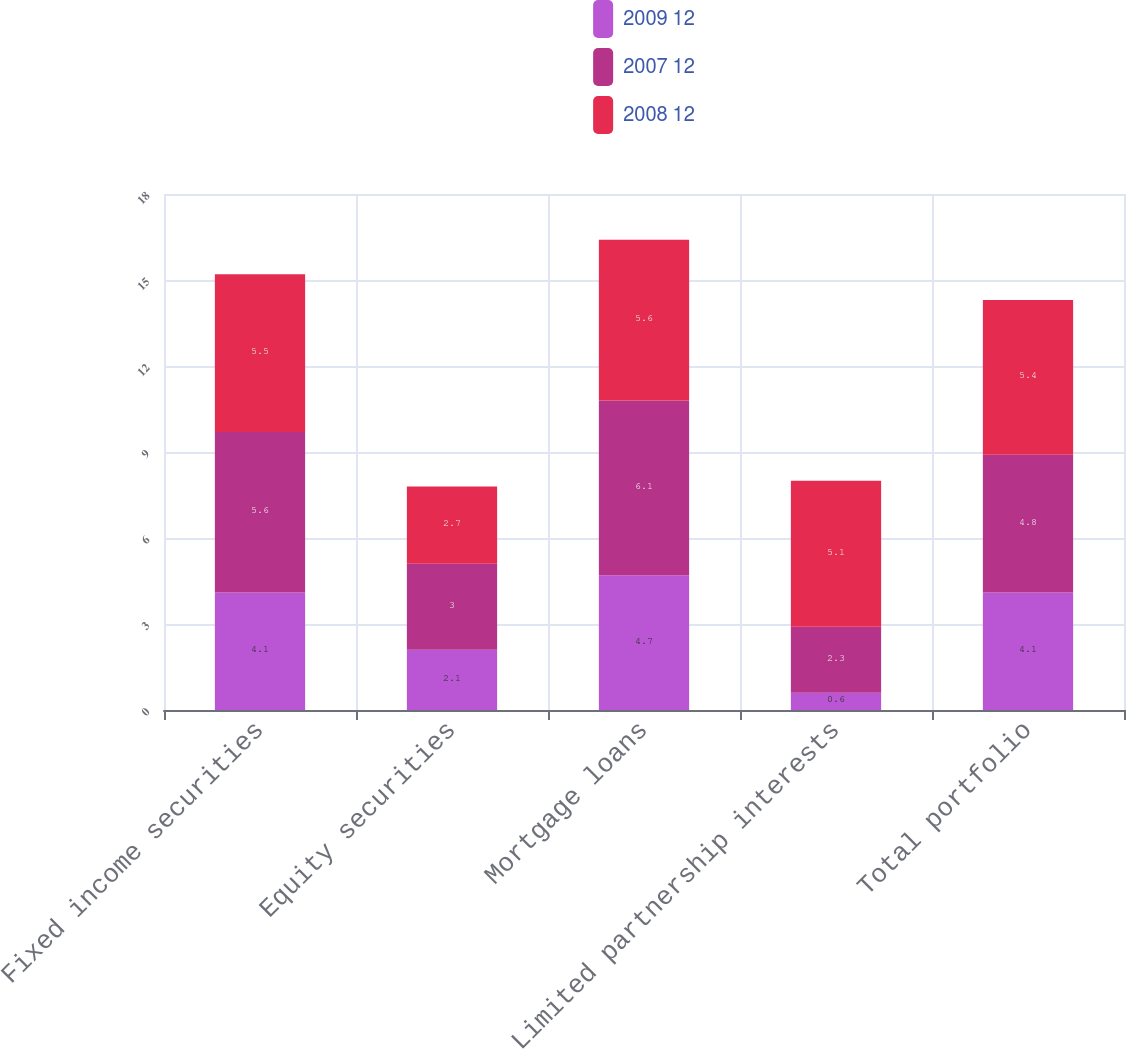<chart> <loc_0><loc_0><loc_500><loc_500><stacked_bar_chart><ecel><fcel>Fixed income securities<fcel>Equity securities<fcel>Mortgage loans<fcel>Limited partnership interests<fcel>Total portfolio<nl><fcel>2009 12<fcel>4.1<fcel>2.1<fcel>4.7<fcel>0.6<fcel>4.1<nl><fcel>2007 12<fcel>5.6<fcel>3<fcel>6.1<fcel>2.3<fcel>4.8<nl><fcel>2008 12<fcel>5.5<fcel>2.7<fcel>5.6<fcel>5.1<fcel>5.4<nl></chart> 